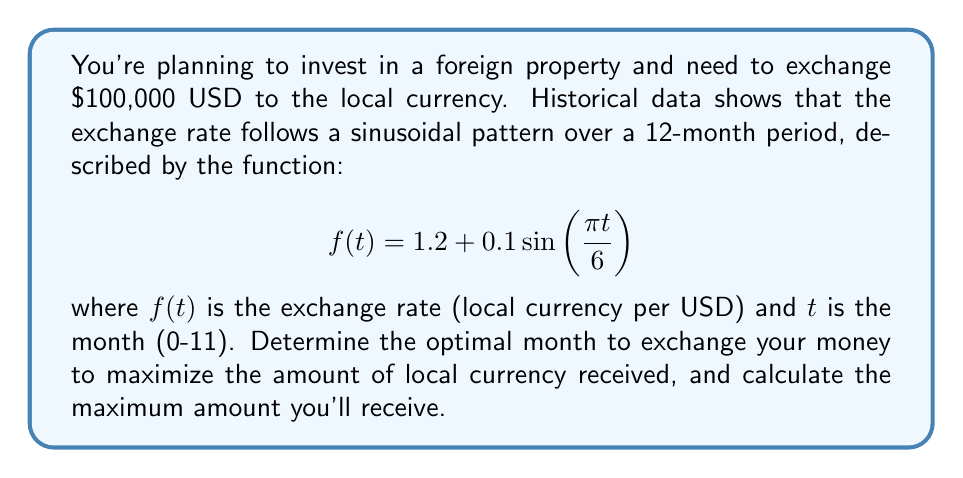Teach me how to tackle this problem. To solve this problem, we need to follow these steps:

1) Find the maximum value of the function $f(t)$ over the domain $[0, 11]$.

2) The sine function reaches its maximum value of 1 when its argument is $\frac{\pi}{2}$. So, we need to solve:

   $$\frac{\pi t}{6} = \frac{\pi}{2}$$

3) Solving this equation:
   
   $$t = 3$$

4) This means the exchange rate is highest at $t = 3$, which corresponds to the 4th month (since we start counting from 0).

5) To find the maximum exchange rate, we substitute $t = 3$ into our original function:

   $$f(3) = 1.2 + 0.1\sin(\frac{\pi \cdot 3}{6}) = 1.2 + 0.1 = 1.3$$

6) Therefore, the maximum exchange rate is 1.3 local currency per USD.

7) To calculate the amount of local currency received, multiply the exchange rate by the amount of USD:

   $$100,000 \cdot 1.3 = 130,000$$

Thus, the optimal time to exchange is in the 4th month, and you'll receive 130,000 units of the local currency.
Answer: 4th month; 130,000 local currency units 